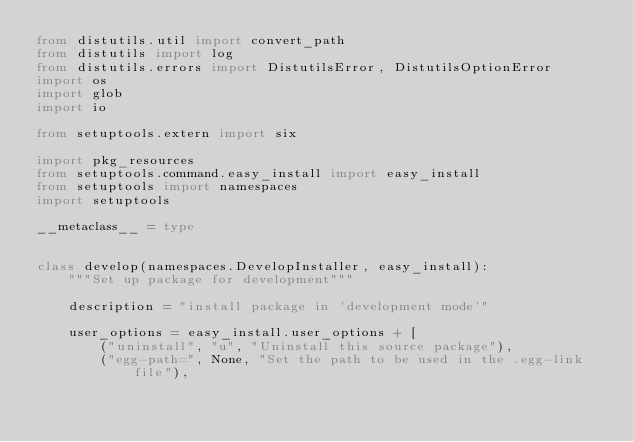Convert code to text. <code><loc_0><loc_0><loc_500><loc_500><_Python_>from distutils.util import convert_path
from distutils import log
from distutils.errors import DistutilsError, DistutilsOptionError
import os
import glob
import io

from setuptools.extern import six

import pkg_resources
from setuptools.command.easy_install import easy_install
from setuptools import namespaces
import setuptools

__metaclass__ = type


class develop(namespaces.DevelopInstaller, easy_install):
    """Set up package for development"""

    description = "install package in 'development mode'"

    user_options = easy_install.user_options + [
        ("uninstall", "u", "Uninstall this source package"),
        ("egg-path=", None, "Set the path to be used in the .egg-link file"),</code> 